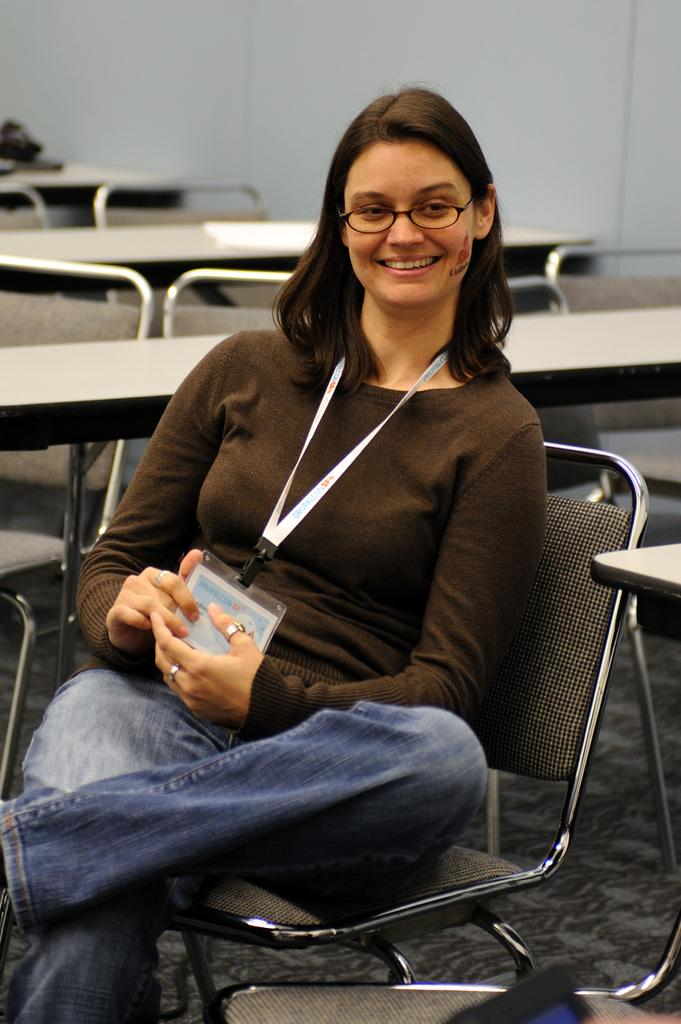What is the primary subject of the image? There is a woman in the image. What is the woman doing in the image? The woman is sitting on a chair. Can you describe any accessories the woman is wearing? The woman is wearing an ID card and has spectacles. What is the woman's facial expression in the image? The woman is smiling. What type of surface is visible beneath the woman? There is a floor in the image. What other objects can be seen in the image? There are tables in the image. What is visible in the background of the image? There is a wall in the background of the image. What is the woman's income based on the image? There is no information about the woman's income in the image. How many daughters does the woman have in the image? There is no information about the woman's daughters in the image. 